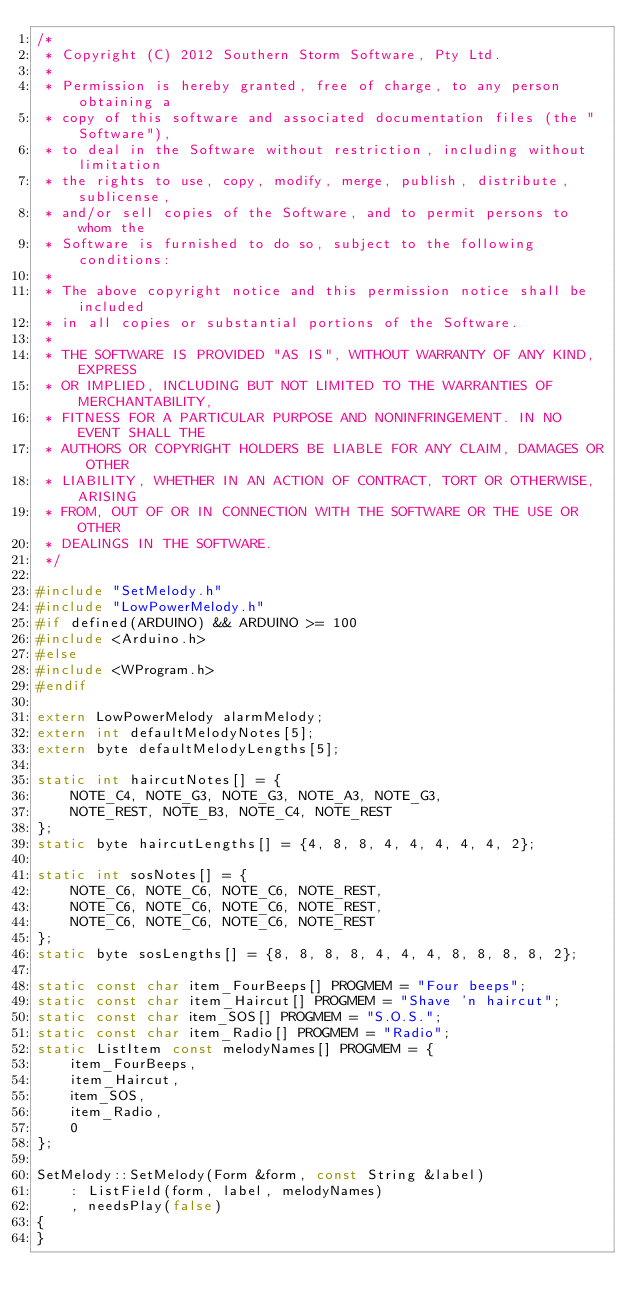<code> <loc_0><loc_0><loc_500><loc_500><_C++_>/*
 * Copyright (C) 2012 Southern Storm Software, Pty Ltd.
 *
 * Permission is hereby granted, free of charge, to any person obtaining a
 * copy of this software and associated documentation files (the "Software"),
 * to deal in the Software without restriction, including without limitation
 * the rights to use, copy, modify, merge, publish, distribute, sublicense,
 * and/or sell copies of the Software, and to permit persons to whom the
 * Software is furnished to do so, subject to the following conditions:
 *
 * The above copyright notice and this permission notice shall be included
 * in all copies or substantial portions of the Software.
 *
 * THE SOFTWARE IS PROVIDED "AS IS", WITHOUT WARRANTY OF ANY KIND, EXPRESS
 * OR IMPLIED, INCLUDING BUT NOT LIMITED TO THE WARRANTIES OF MERCHANTABILITY,
 * FITNESS FOR A PARTICULAR PURPOSE AND NONINFRINGEMENT. IN NO EVENT SHALL THE
 * AUTHORS OR COPYRIGHT HOLDERS BE LIABLE FOR ANY CLAIM, DAMAGES OR OTHER
 * LIABILITY, WHETHER IN AN ACTION OF CONTRACT, TORT OR OTHERWISE, ARISING
 * FROM, OUT OF OR IN CONNECTION WITH THE SOFTWARE OR THE USE OR OTHER
 * DEALINGS IN THE SOFTWARE.
 */

#include "SetMelody.h"
#include "LowPowerMelody.h"
#if defined(ARDUINO) && ARDUINO >= 100
#include <Arduino.h>
#else
#include <WProgram.h>
#endif

extern LowPowerMelody alarmMelody;
extern int defaultMelodyNotes[5];
extern byte defaultMelodyLengths[5];

static int haircutNotes[] = {
    NOTE_C4, NOTE_G3, NOTE_G3, NOTE_A3, NOTE_G3,
    NOTE_REST, NOTE_B3, NOTE_C4, NOTE_REST
};
static byte haircutLengths[] = {4, 8, 8, 4, 4, 4, 4, 4, 2};

static int sosNotes[] = {
    NOTE_C6, NOTE_C6, NOTE_C6, NOTE_REST,
    NOTE_C6, NOTE_C6, NOTE_C6, NOTE_REST,
    NOTE_C6, NOTE_C6, NOTE_C6, NOTE_REST
};
static byte sosLengths[] = {8, 8, 8, 8, 4, 4, 4, 8, 8, 8, 8, 2};

static const char item_FourBeeps[] PROGMEM = "Four beeps";
static const char item_Haircut[] PROGMEM = "Shave 'n haircut";
static const char item_SOS[] PROGMEM = "S.O.S.";
static const char item_Radio[] PROGMEM = "Radio";
static ListItem const melodyNames[] PROGMEM = {
    item_FourBeeps,
    item_Haircut,
    item_SOS,
    item_Radio,
    0
};

SetMelody::SetMelody(Form &form, const String &label)
    : ListField(form, label, melodyNames)
    , needsPlay(false)
{
}
</code> 